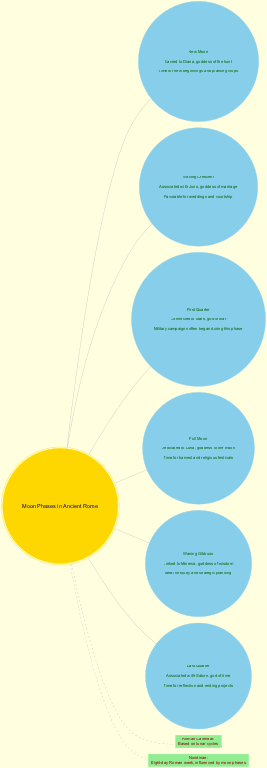What is the significance of the Full Moon? The diagram indicates that the Full Moon is dedicated to Luna, the goddess of the moon. This is found by referencing the phase labeled "Full Moon" in the diagram.
Answer: Dedicated to Luna, goddess of the moon What phase is associated with Juno? The Waxing Crescent phase is linked to Juno, as shown in the diagram where each phase is described alongside its significance.
Answer: Waxing Crescent How many moon phases are illustrated in the diagram? The diagram lists a total of six distinct phases of the moon, which can be counted from the provided phases section.
Answer: 6 During which moon phase do military campaigns typically begin? According to the diagram, the First Quarter is connected to Mars and marked as the phase during which military campaigns often began. This information is found in the "First Quarter" section.
Answer: First Quarter What is the daily life significance of the Waning Gibbous phase? The diagram explains that the Waning Gibbous phase is ideal for study and strategic planning, as detailed under the "Waning Gibbous" section.
Answer: Ideal for study and strategic planning Which goddess is linked to the New Moon? The diagram indicates that the New Moon is sacred to Diana, the goddess of the hunt, found in the description under the "New Moon" phase.
Answer: Diana What does the Roman calendar rely on according to the diagram? The diagram specifies that the Roman calendar is based on lunar cycles, providing this information in its dedicated section.
Answer: Based on lunar cycles What is the significance of the Last Quarter in daily life? The diagram shows that the Last Quarter is a time for reflection and ending projects, which can be found by examining the description under the "Last Quarter" phase.
Answer: Time for reflection and ending projects What color denotes the central node in the diagram? The central node representing the "Moon Phases in Ancient Rome" is colored gold, as indicated in the diagram's formatting details.
Answer: Gold 